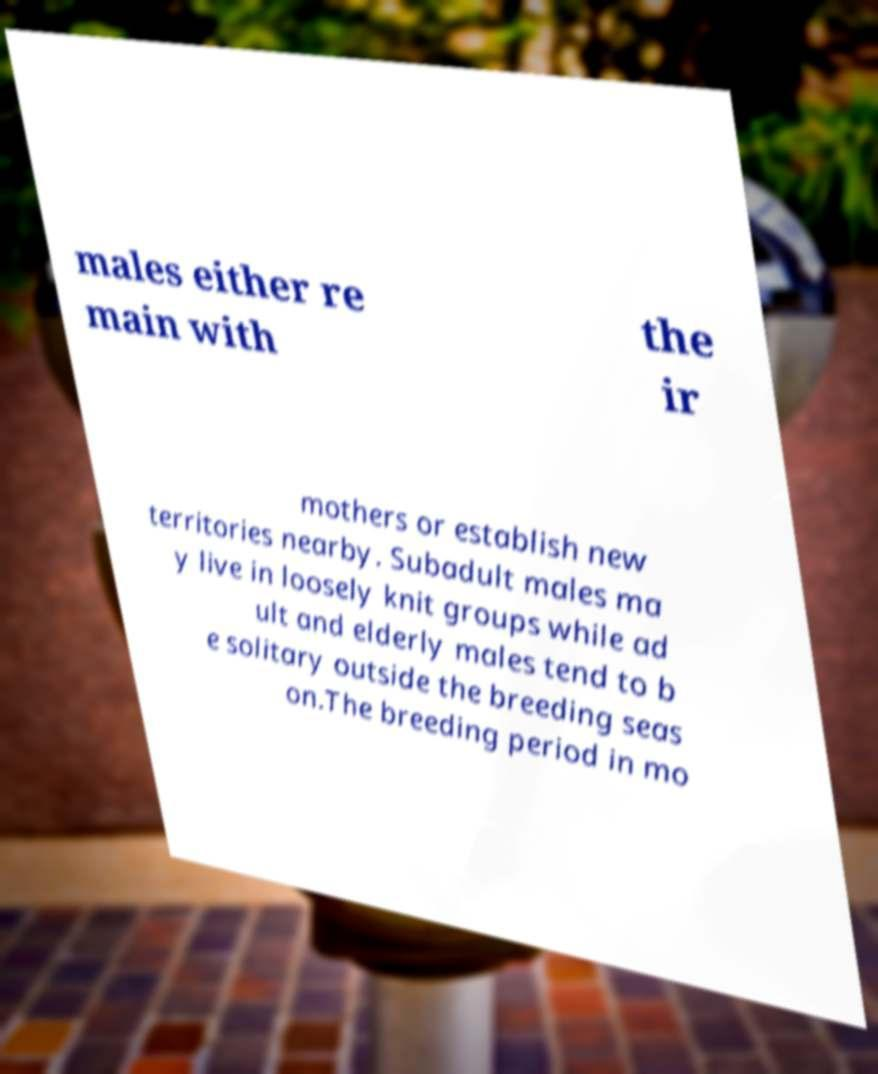I need the written content from this picture converted into text. Can you do that? males either re main with the ir mothers or establish new territories nearby. Subadult males ma y live in loosely knit groups while ad ult and elderly males tend to b e solitary outside the breeding seas on.The breeding period in mo 